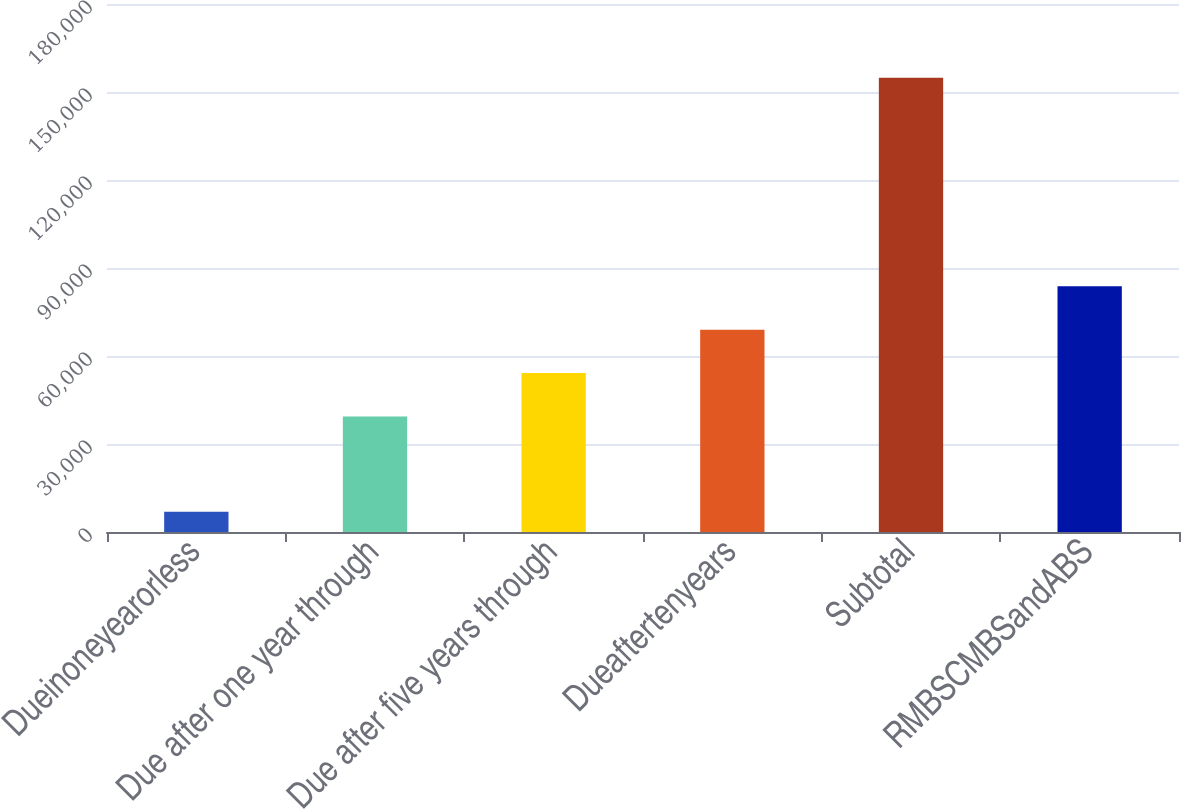Convert chart. <chart><loc_0><loc_0><loc_500><loc_500><bar_chart><fcel>Dueinoneyearorless<fcel>Due after one year through<fcel>Due after five years through<fcel>Dueaftertenyears<fcel>Subtotal<fcel>RMBSCMBSandABS<nl><fcel>6924<fcel>39399<fcel>54190.4<fcel>68981.8<fcel>154838<fcel>83773.2<nl></chart> 